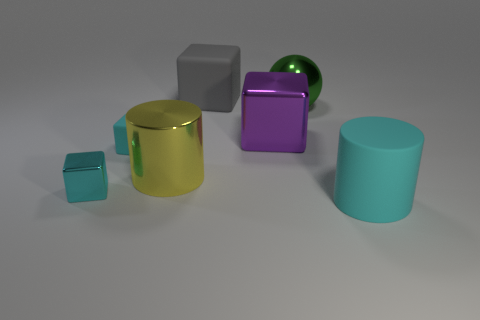Which objects in the image are shiny? The green ball and the golden cylinder appear to have shiny surfaces, reflecting light more than the other objects. Is there any object that stands out in size? Yes, the teal cylinder on the right side of the image is notably larger compared to the other objects. What shapes are present in the image? The shapes visible are spherical, cylindrical, and cuboid. Each shape comes in various sizes and colors. 